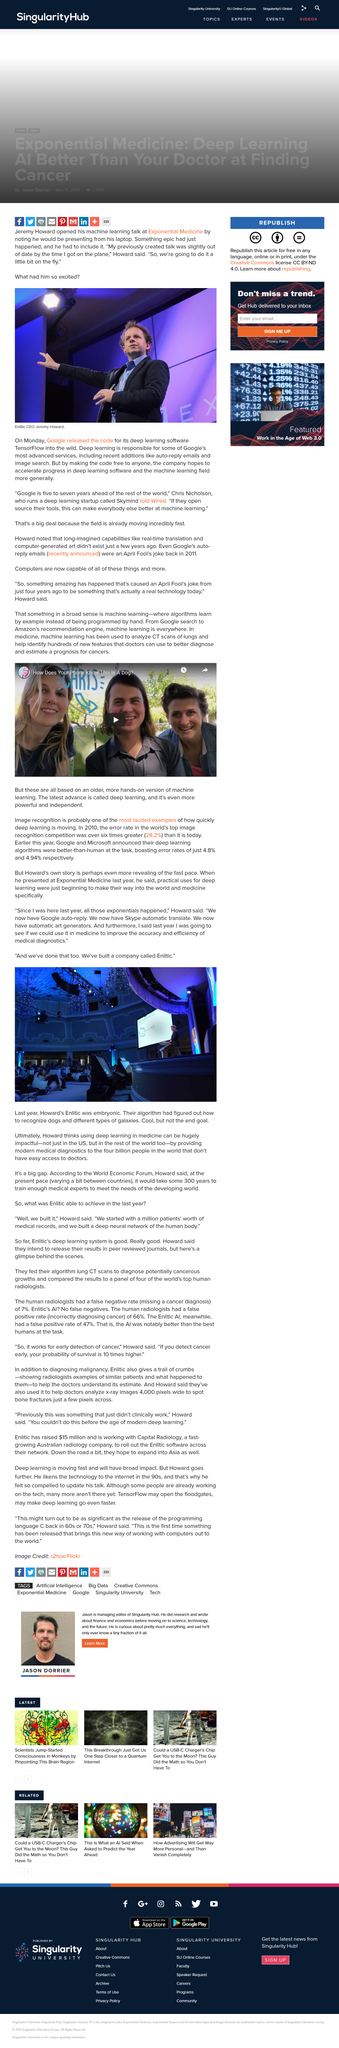Point out several critical features in this image. Enlicit is the name of the company that Howard built. Enlitic CEO Jeremy Howard was excited because Google had released the code for its deep learning software, TensorFlow, into the wild. Image recognition is a prime example of the rapid advancements being made in the field of deep learning. The person in the photograph is Howard, and he is the one speaking. The latest advance in machine learning is called deep learning, which is powerful and independent. 